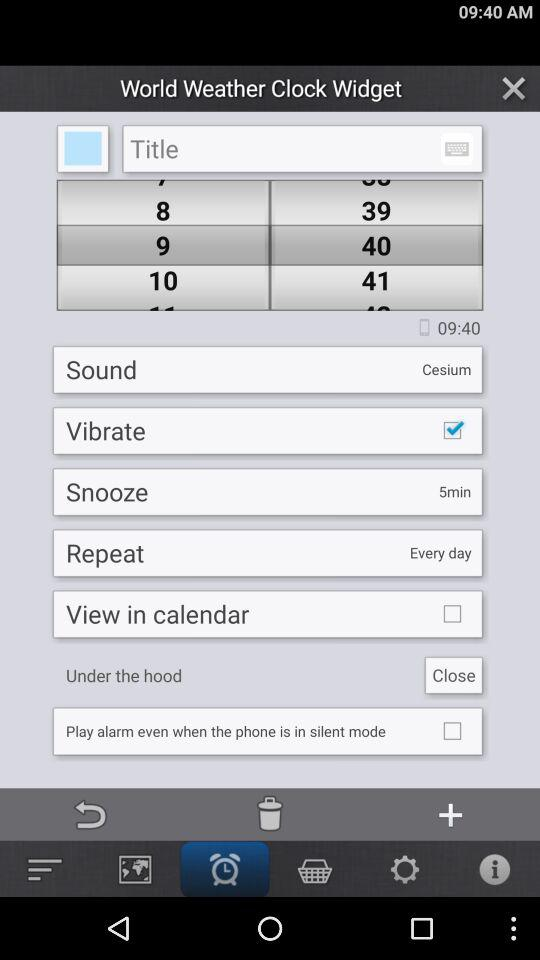What is the title?
When the provided information is insufficient, respond with <no answer>. <no answer> 